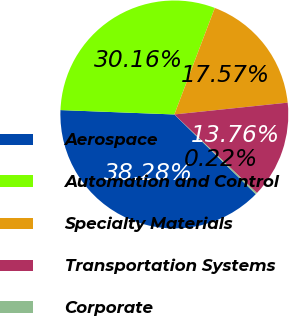<chart> <loc_0><loc_0><loc_500><loc_500><pie_chart><fcel>Aerospace<fcel>Automation and Control<fcel>Specialty Materials<fcel>Transportation Systems<fcel>Corporate<nl><fcel>38.28%<fcel>30.16%<fcel>17.57%<fcel>13.76%<fcel>0.22%<nl></chart> 